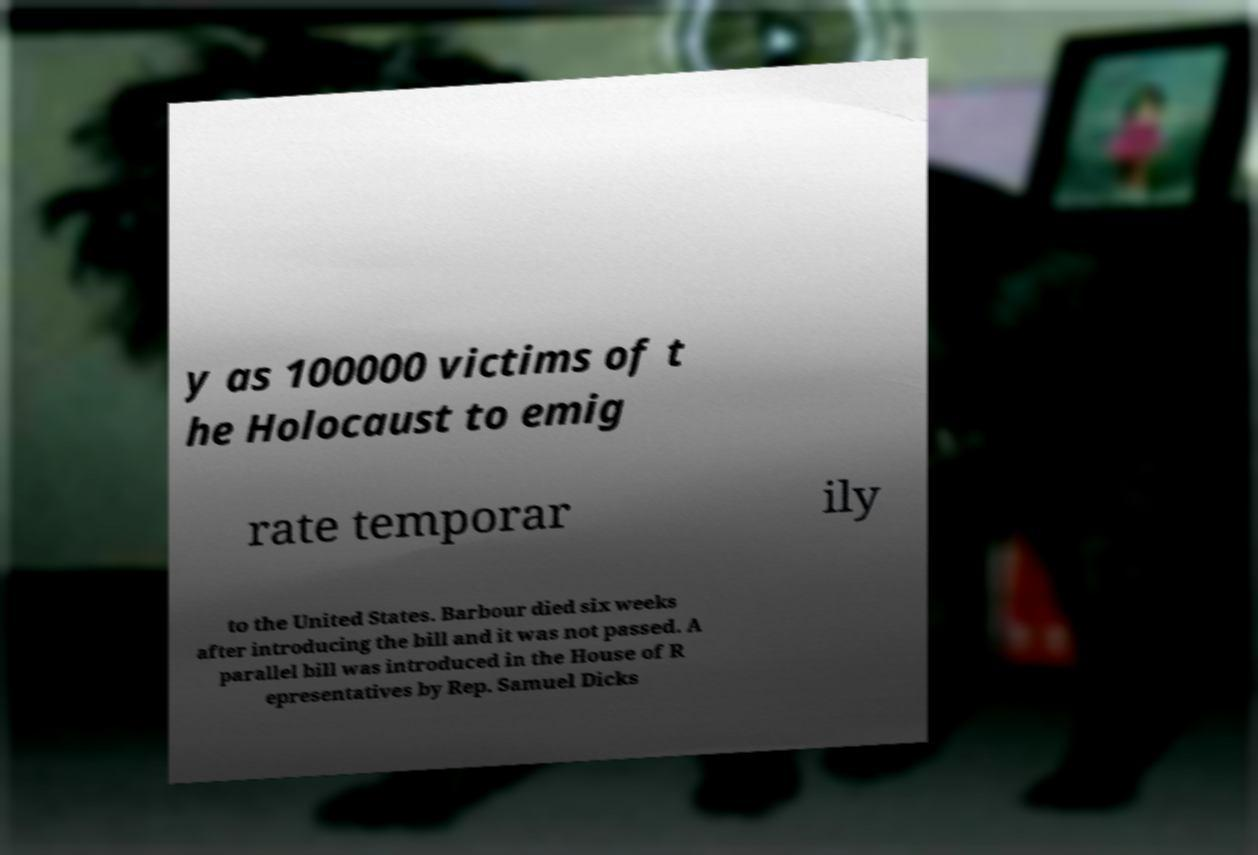For documentation purposes, I need the text within this image transcribed. Could you provide that? y as 100000 victims of t he Holocaust to emig rate temporar ily to the United States. Barbour died six weeks after introducing the bill and it was not passed. A parallel bill was introduced in the House of R epresentatives by Rep. Samuel Dicks 